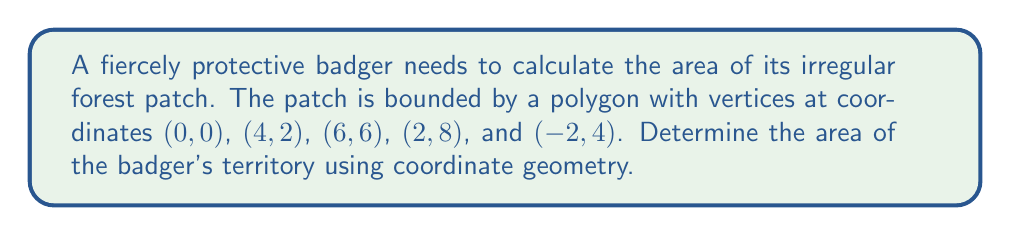Provide a solution to this math problem. To find the area of this irregular forest patch, we can use the Shoelace formula (also known as the surveyor's formula). The steps are as follows:

1) First, list the coordinates in order, repeating the first coordinate at the end:
   $(0,0)$, $(4,2)$, $(6,6)$, $(2,8)$, $(-2,4)$, $(0,0)$

2) Apply the Shoelace formula:
   $$A = \frac{1}{2}|\sum_{i=1}^{n} (x_i y_{i+1} - x_{i+1} y_i)|$$

   Where $(x_i, y_i)$ are the coordinates of the $i$-th vertex.

3) Calculate each term:
   $$(0 \cdot 2) - (4 \cdot 0) = 0 - 0 = 0$$
   $$(4 \cdot 6) - (6 \cdot 2) = 24 - 12 = 12$$
   $$(6 \cdot 8) - (2 \cdot 6) = 48 - 12 = 36$$
   $$(2 \cdot 4) - (-2 \cdot 8) = 8 + 16 = 24$$
   $$(-2 \cdot 0) - (0 \cdot 4) = 0 - 0 = 0$$

4) Sum these values:
   $$0 + 12 + 36 + 24 + 0 = 72$$

5) Take the absolute value and divide by 2:
   $$\frac{1}{2}|72| = 36$$

Therefore, the area of the badger's forest patch is 36 square units.
Answer: 36 square units 